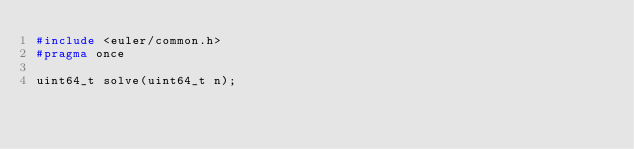<code> <loc_0><loc_0><loc_500><loc_500><_C_>#include <euler/common.h>
#pragma once

uint64_t solve(uint64_t n);
</code> 